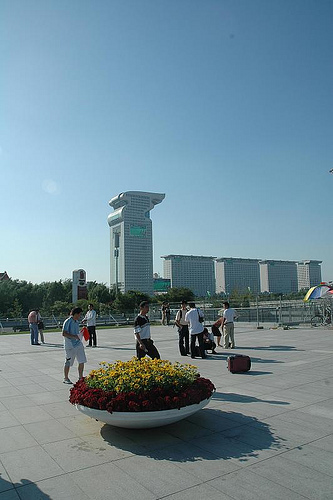<image>
Is the plant behind the person? No. The plant is not behind the person. From this viewpoint, the plant appears to be positioned elsewhere in the scene. Is there a man above the flowers? No. The man is not positioned above the flowers. The vertical arrangement shows a different relationship. 